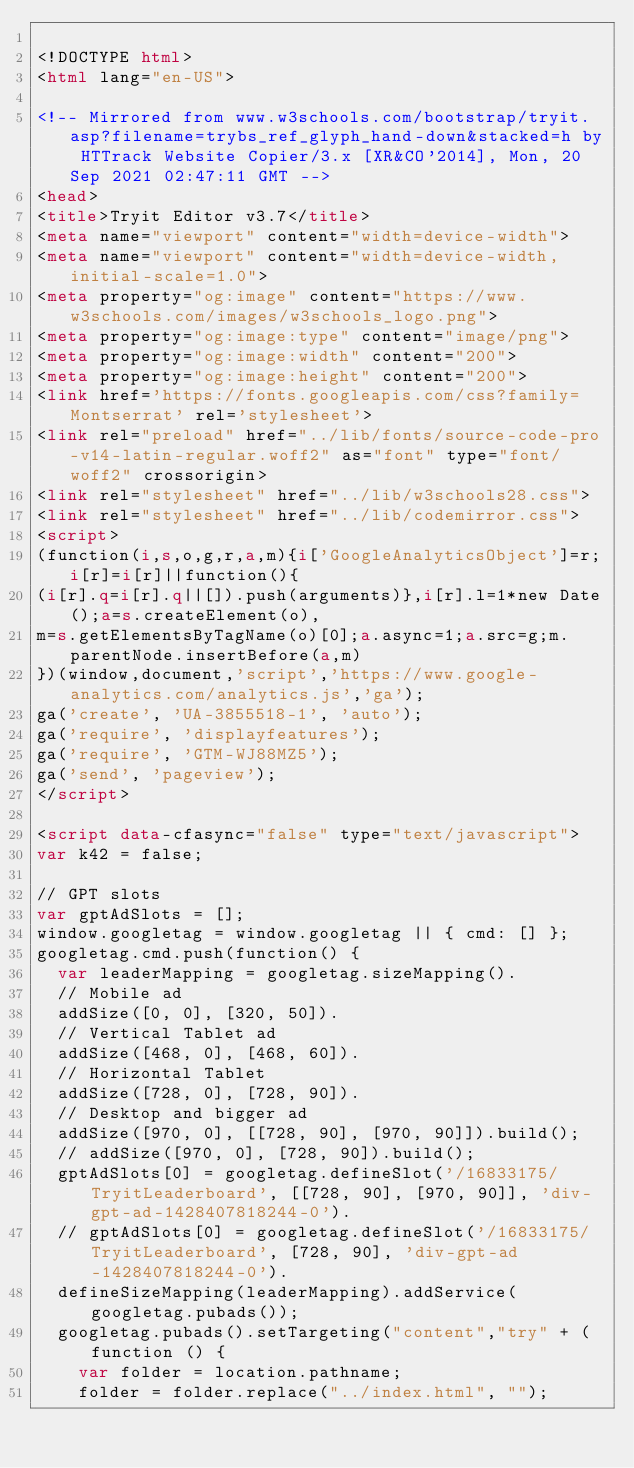Convert code to text. <code><loc_0><loc_0><loc_500><loc_500><_HTML_>
<!DOCTYPE html>
<html lang="en-US">

<!-- Mirrored from www.w3schools.com/bootstrap/tryit.asp?filename=trybs_ref_glyph_hand-down&stacked=h by HTTrack Website Copier/3.x [XR&CO'2014], Mon, 20 Sep 2021 02:47:11 GMT -->
<head>
<title>Tryit Editor v3.7</title>
<meta name="viewport" content="width=device-width">
<meta name="viewport" content="width=device-width, initial-scale=1.0">
<meta property="og:image" content="https://www.w3schools.com/images/w3schools_logo.png">
<meta property="og:image:type" content="image/png">
<meta property="og:image:width" content="200">
<meta property="og:image:height" content="200">
<link href='https://fonts.googleapis.com/css?family=Montserrat' rel='stylesheet'>
<link rel="preload" href="../lib/fonts/source-code-pro-v14-latin-regular.woff2" as="font" type="font/woff2" crossorigin>
<link rel="stylesheet" href="../lib/w3schools28.css">
<link rel="stylesheet" href="../lib/codemirror.css">
<script>
(function(i,s,o,g,r,a,m){i['GoogleAnalyticsObject']=r;i[r]=i[r]||function(){
(i[r].q=i[r].q||[]).push(arguments)},i[r].l=1*new Date();a=s.createElement(o),
m=s.getElementsByTagName(o)[0];a.async=1;a.src=g;m.parentNode.insertBefore(a,m)
})(window,document,'script','https://www.google-analytics.com/analytics.js','ga');
ga('create', 'UA-3855518-1', 'auto');
ga('require', 'displayfeatures');
ga('require', 'GTM-WJ88MZ5');
ga('send', 'pageview');
</script>

<script data-cfasync="false" type="text/javascript">
var k42 = false;

// GPT slots
var gptAdSlots = [];
window.googletag = window.googletag || { cmd: [] };
googletag.cmd.push(function() {
  var leaderMapping = googletag.sizeMapping().
  // Mobile ad
  addSize([0, 0], [320, 50]). 
  // Vertical Tablet ad
  addSize([468, 0], [468, 60]). 
  // Horizontal Tablet
  addSize([728, 0], [728, 90]).
  // Desktop and bigger ad
  addSize([970, 0], [[728, 90], [970, 90]]).build();
  // addSize([970, 0], [728, 90]).build();
  gptAdSlots[0] = googletag.defineSlot('/16833175/TryitLeaderboard', [[728, 90], [970, 90]], 'div-gpt-ad-1428407818244-0').
  // gptAdSlots[0] = googletag.defineSlot('/16833175/TryitLeaderboard', [728, 90], 'div-gpt-ad-1428407818244-0').
  defineSizeMapping(leaderMapping).addService(googletag.pubads());
  googletag.pubads().setTargeting("content","try" + (function () {
    var folder = location.pathname;
    folder = folder.replace("../index.html", "");</code> 